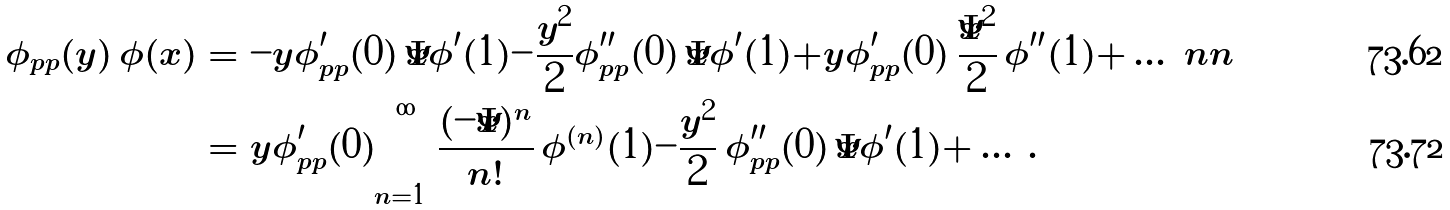<formula> <loc_0><loc_0><loc_500><loc_500>\phi _ { p p } ( y ) \, \phi ( x ) & = - y \phi _ { p p } ^ { \prime } ( 0 ) \, \bar { x } \phi ^ { \prime } ( 1 ) - \frac { y ^ { 2 } } { 2 } \phi _ { p p } ^ { \prime \prime } ( 0 ) \, \bar { x } \phi ^ { \prime } ( 1 ) + y \phi _ { p p } ^ { \prime } ( 0 ) \, \frac { \bar { x } ^ { 2 } } { 2 } \, \phi ^ { \prime \prime } ( 1 ) + \dots \ n n \\ & = y \phi _ { p p } ^ { \prime } ( 0 ) \sum _ { n = 1 } ^ { \infty } \frac { ( - \bar { x } ) ^ { n } } { n ! } \, \phi ^ { ( n ) } ( 1 ) - \frac { y ^ { 2 } } { 2 } \, \phi _ { p p } ^ { \prime \prime } ( 0 ) \, \bar { x } \phi ^ { \prime } ( 1 ) + \dots \, .</formula> 